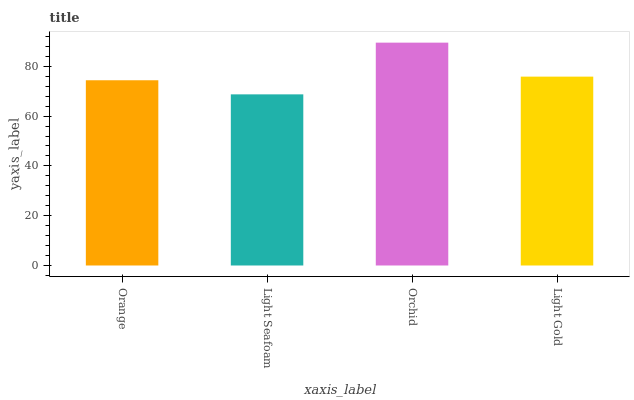Is Light Seafoam the minimum?
Answer yes or no. Yes. Is Orchid the maximum?
Answer yes or no. Yes. Is Orchid the minimum?
Answer yes or no. No. Is Light Seafoam the maximum?
Answer yes or no. No. Is Orchid greater than Light Seafoam?
Answer yes or no. Yes. Is Light Seafoam less than Orchid?
Answer yes or no. Yes. Is Light Seafoam greater than Orchid?
Answer yes or no. No. Is Orchid less than Light Seafoam?
Answer yes or no. No. Is Light Gold the high median?
Answer yes or no. Yes. Is Orange the low median?
Answer yes or no. Yes. Is Orchid the high median?
Answer yes or no. No. Is Light Seafoam the low median?
Answer yes or no. No. 